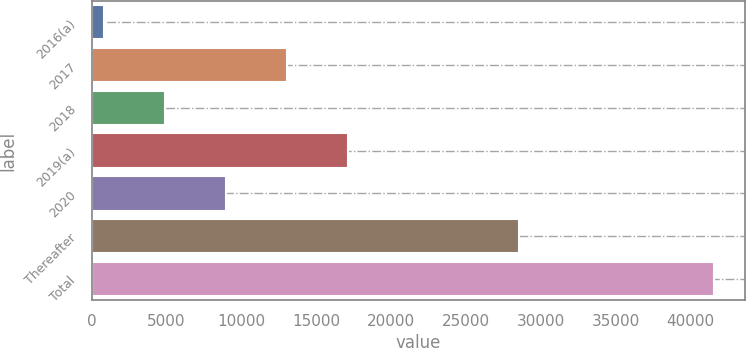<chart> <loc_0><loc_0><loc_500><loc_500><bar_chart><fcel>2016(a)<fcel>2017<fcel>2018<fcel>2019(a)<fcel>2020<fcel>Thereafter<fcel>Total<nl><fcel>821<fcel>13040.6<fcel>4894.2<fcel>17113.8<fcel>8967.4<fcel>28571<fcel>41553<nl></chart> 